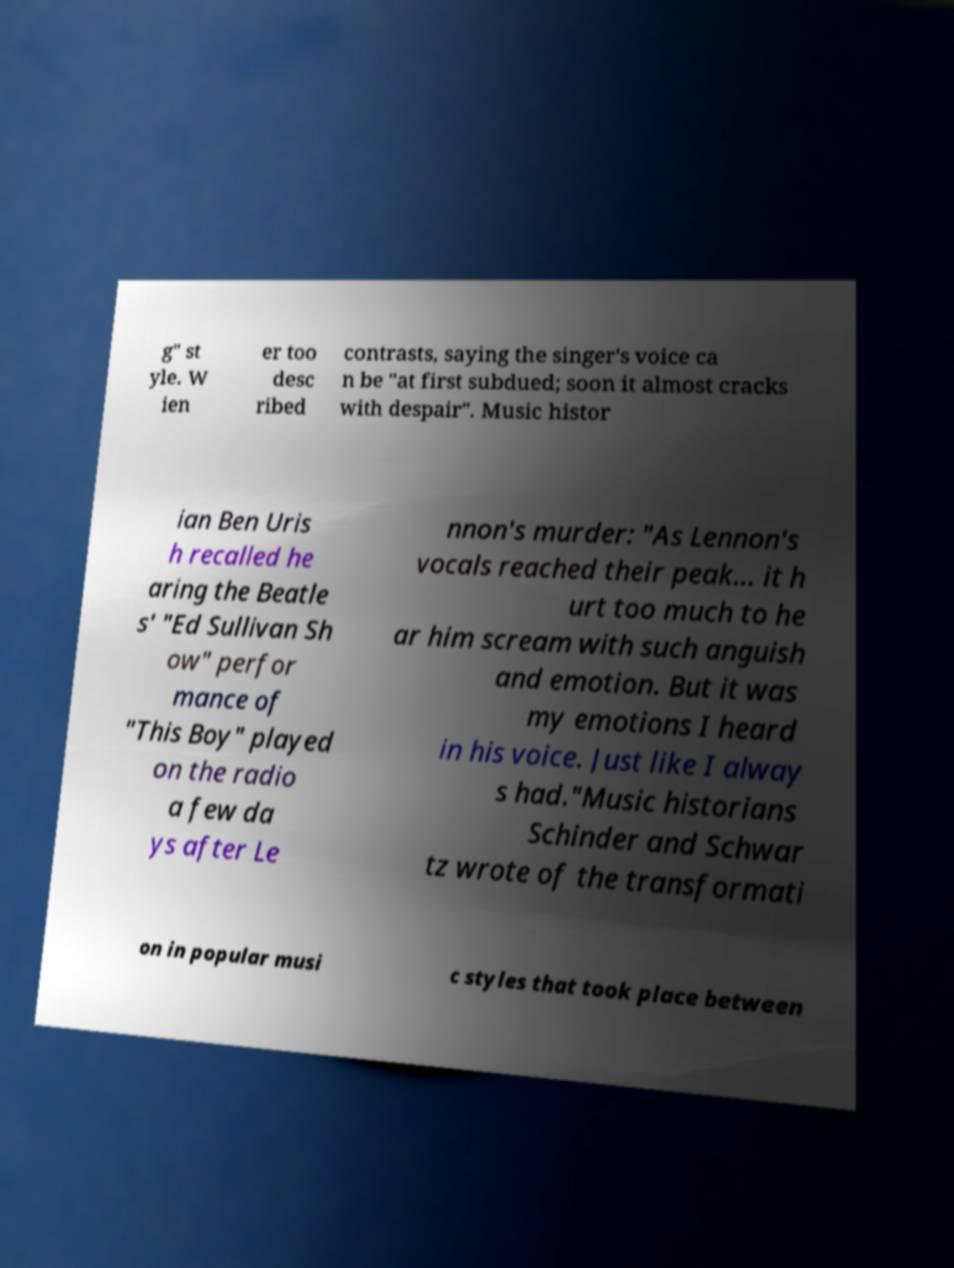Can you accurately transcribe the text from the provided image for me? g" st yle. W ien er too desc ribed contrasts, saying the singer's voice ca n be "at first subdued; soon it almost cracks with despair". Music histor ian Ben Uris h recalled he aring the Beatle s' "Ed Sullivan Sh ow" perfor mance of "This Boy" played on the radio a few da ys after Le nnon's murder: "As Lennon's vocals reached their peak... it h urt too much to he ar him scream with such anguish and emotion. But it was my emotions I heard in his voice. Just like I alway s had."Music historians Schinder and Schwar tz wrote of the transformati on in popular musi c styles that took place between 